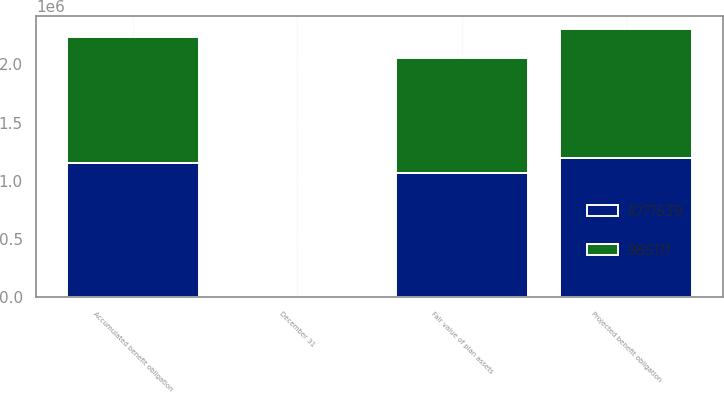Convert chart. <chart><loc_0><loc_0><loc_500><loc_500><stacked_bar_chart><ecel><fcel>December 31<fcel>Projected benefit obligation<fcel>Accumulated benefit obligation<fcel>Fair value of plan assets<nl><fcel>985111<fcel>2015<fcel>1.11023e+06<fcel>1.081e+06<fcel>985111<nl><fcel>1.07154e+06<fcel>2014<fcel>1.19315e+06<fcel>1.15121e+06<fcel>1.07154e+06<nl></chart> 